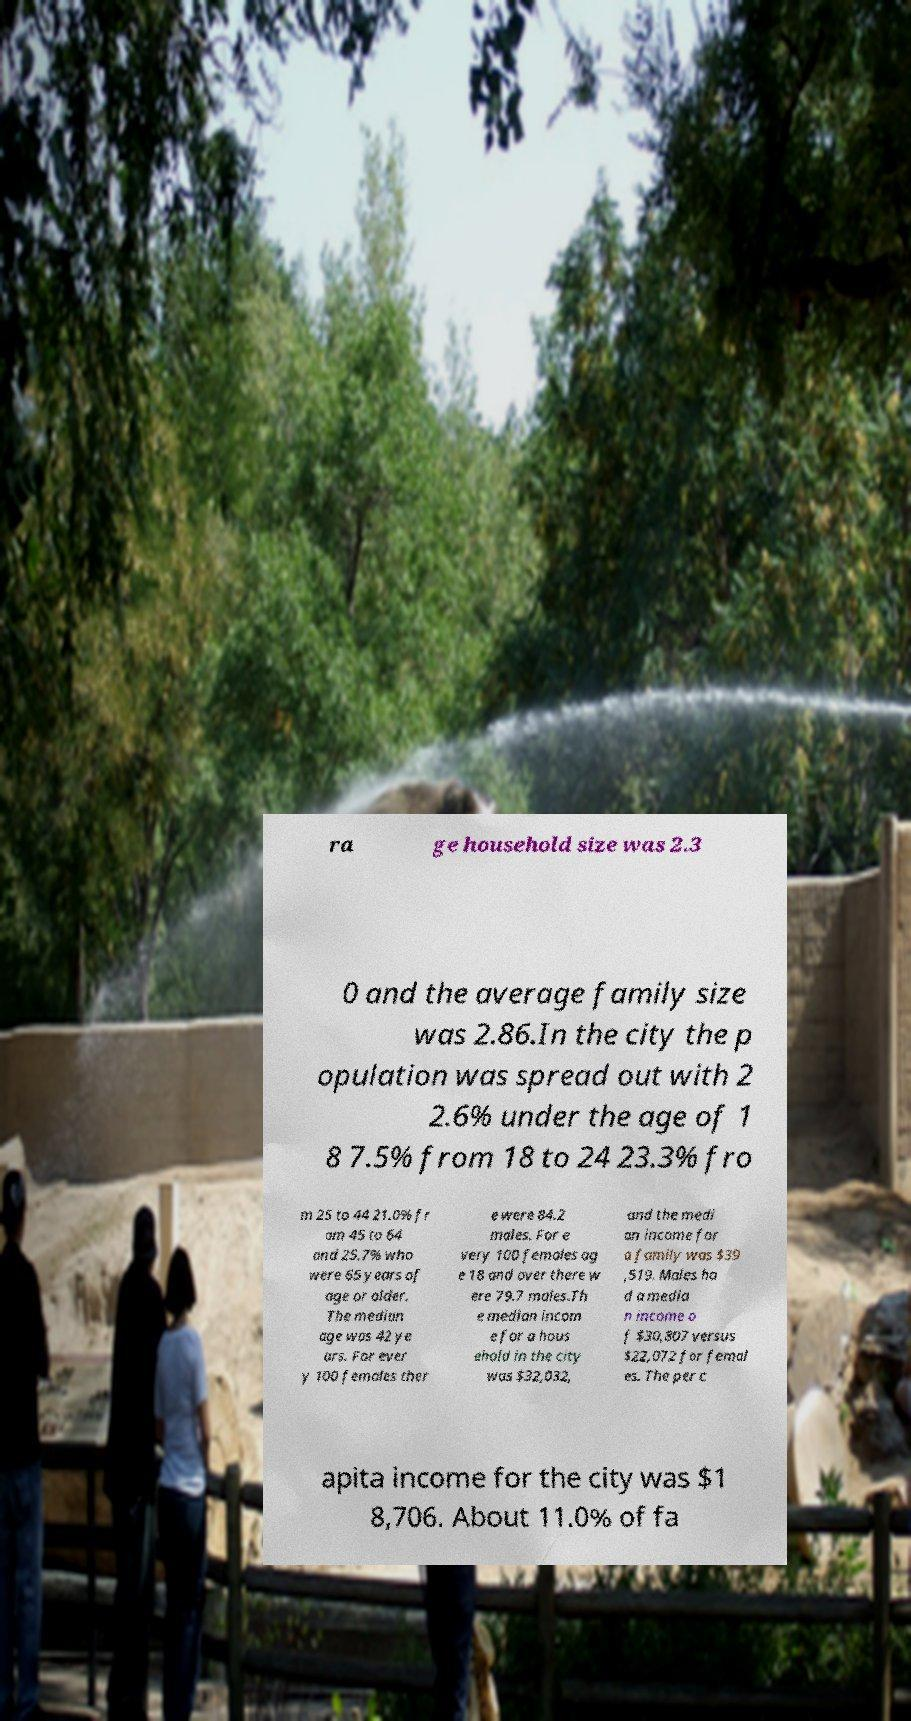Can you accurately transcribe the text from the provided image for me? ra ge household size was 2.3 0 and the average family size was 2.86.In the city the p opulation was spread out with 2 2.6% under the age of 1 8 7.5% from 18 to 24 23.3% fro m 25 to 44 21.0% fr om 45 to 64 and 25.7% who were 65 years of age or older. The median age was 42 ye ars. For ever y 100 females ther e were 84.2 males. For e very 100 females ag e 18 and over there w ere 79.7 males.Th e median incom e for a hous ehold in the city was $32,032, and the medi an income for a family was $39 ,519. Males ha d a media n income o f $30,807 versus $22,072 for femal es. The per c apita income for the city was $1 8,706. About 11.0% of fa 